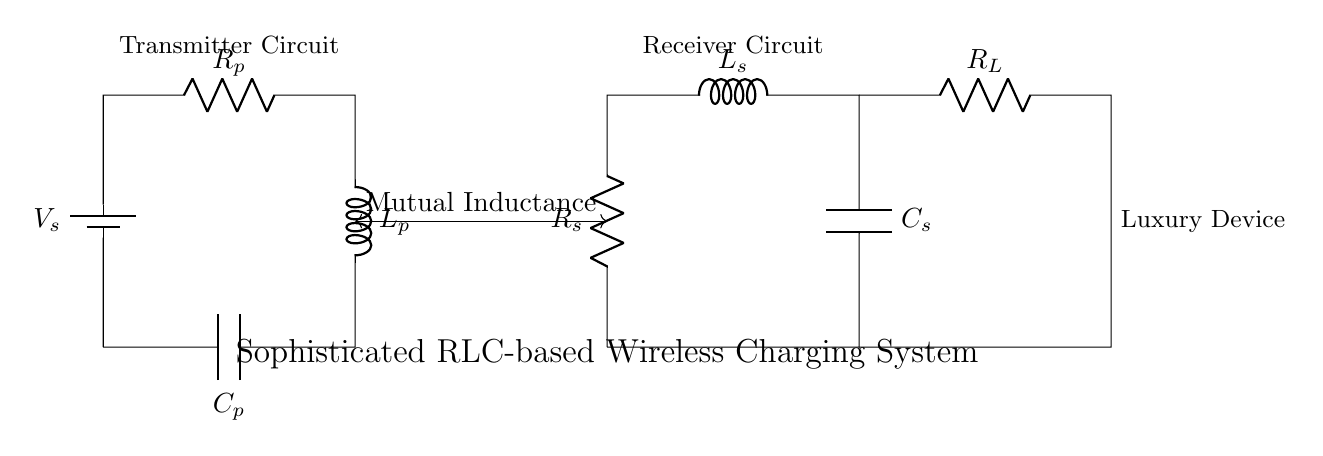What is the voltage source in the circuit? The voltage source is labeled as V_s, which represents the supply voltage for the transmitter circuit.
Answer: V_s How many resistors are present in the circuit? The circuit contains two resistors: R_p in the transmitter and R_s in the receiver.
Answer: 2 What is the role of mutual inductance in this circuit? Mutual inductance facilitates the energy transfer between the transmitter and receiver circuits through the electromagnetic field generated by the inductors L_p and L_s.
Answer: Energy transfer Which components are part of the transmitter circuit? The transmitter circuit consists of the voltage source V_s, resistor R_p, inductor L_p, and capacitor C_p, as indicated in the diagram.
Answer: V_s, R_p, L_p, C_p How do you compute the total impedance of this RLC circuit? Total impedance in a series RLC circuit can be computed using the formula Z = R + j(ωL - 1/ωC), where R is resistance, L is inductance, C is capacitance, and ω is the angular frequency of the circuit.
Answer: Use impedance formula What happens to the current when resonating at the natural frequency? At resonance, the impedance of the circuit is minimized, leading to maximum current flow through the circuit due to the cancelation of inductive and capacitive reactance.
Answer: Maximum current flow What is the function of the load resistor R_L in this circuit? The load resistor R_L is connected in the receiver circuit, and its function is to provide a path for the current, enabling the luxury device to be powered or charged.
Answer: Powering luxury device 